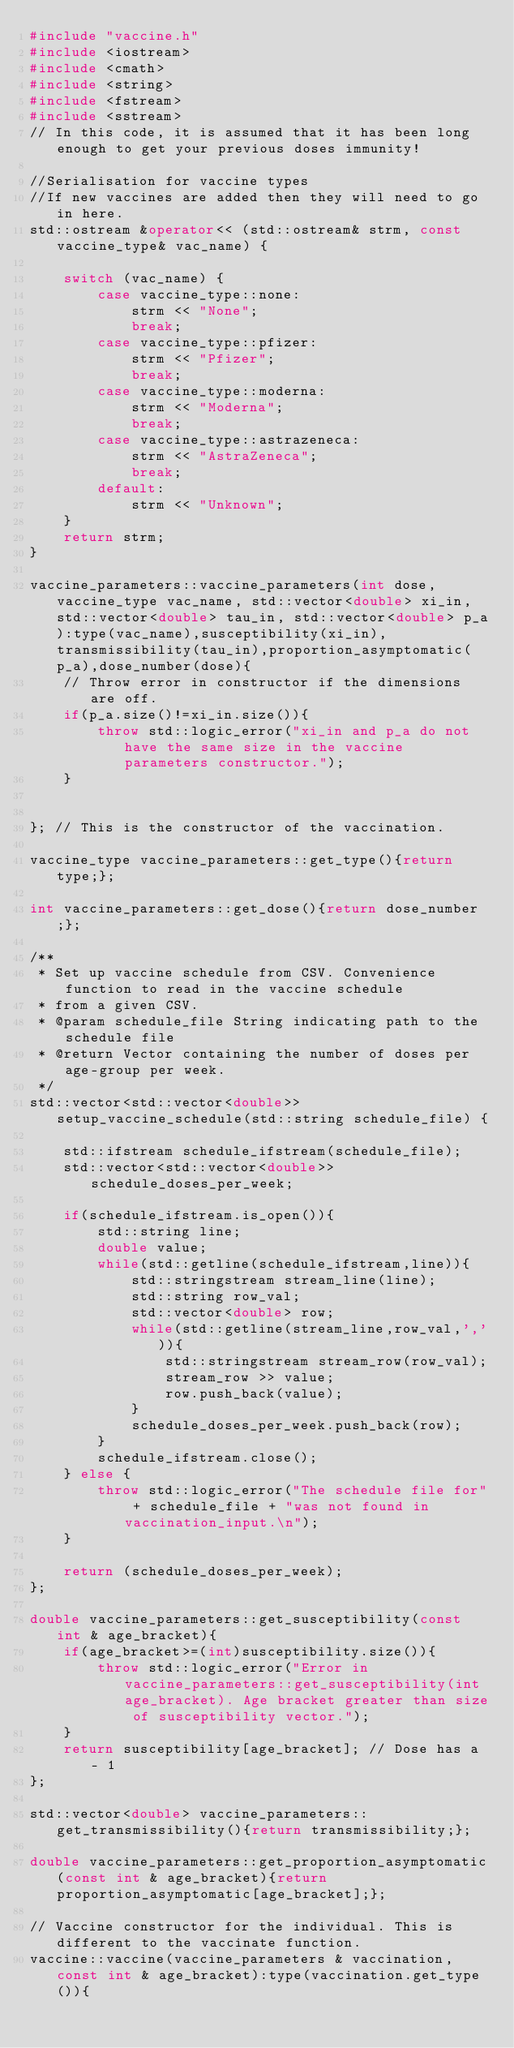<code> <loc_0><loc_0><loc_500><loc_500><_C++_>#include "vaccine.h"
#include <iostream>
#include <cmath>
#include <string>
#include <fstream>
#include <sstream>
// In this code, it is assumed that it has been long enough to get your previous doses immunity!

//Serialisation for vaccine types
//If new vaccines are added then they will need to go in here.
std::ostream &operator<< (std::ostream& strm, const vaccine_type& vac_name) {
    
    switch (vac_name) {
        case vaccine_type::none:
            strm << "None";
            break;
        case vaccine_type::pfizer:
            strm << "Pfizer";
            break;
        case vaccine_type::moderna:
            strm << "Moderna";
            break;
        case vaccine_type::astrazeneca:
            strm << "AstraZeneca";
            break;
        default:
            strm << "Unknown";
    }
    return strm;
}

vaccine_parameters::vaccine_parameters(int dose, vaccine_type vac_name, std::vector<double> xi_in, std::vector<double> tau_in, std::vector<double> p_a):type(vac_name),susceptibility(xi_in),transmissibility(tau_in),proportion_asymptomatic(p_a),dose_number(dose){
    // Throw error in constructor if the dimensions are off.
    if(p_a.size()!=xi_in.size()){
        throw std::logic_error("xi_in and p_a do not have the same size in the vaccine parameters constructor.");
    }
    
    
}; // This is the constructor of the vaccination.

vaccine_type vaccine_parameters::get_type(){return type;};

int vaccine_parameters::get_dose(){return dose_number;};

/**
 * Set up vaccine schedule from CSV. Convenience function to read in the vaccine schedule
 * from a given CSV.
 * @param schedule_file String indicating path to the schedule file
 * @return Vector containing the number of doses per age-group per week.
 */
std::vector<std::vector<double>> setup_vaccine_schedule(std::string schedule_file) {
    
    std::ifstream schedule_ifstream(schedule_file);
    std::vector<std::vector<double>> schedule_doses_per_week;

    if(schedule_ifstream.is_open()){
        std::string line;
        double value;
        while(std::getline(schedule_ifstream,line)){
            std::stringstream stream_line(line);
            std::string row_val;
            std::vector<double> row;
            while(std::getline(stream_line,row_val,',')){
                std::stringstream stream_row(row_val);
                stream_row >> value;
                row.push_back(value);
            }
            schedule_doses_per_week.push_back(row);
        }
        schedule_ifstream.close();
    } else {
        throw std::logic_error("The schedule file for" + schedule_file + "was not found in vaccination_input.\n");
    }

    return (schedule_doses_per_week);
};

double vaccine_parameters::get_susceptibility(const int & age_bracket){
    if(age_bracket>=(int)susceptibility.size()){
        throw std::logic_error("Error in vaccine_parameters::get_susceptibility(int age_bracket). Age bracket greater than size of susceptibility vector.");
    }
    return susceptibility[age_bracket]; // Dose has a - 1
};

std::vector<double> vaccine_parameters::get_transmissibility(){return transmissibility;};

double vaccine_parameters::get_proportion_asymptomatic(const int & age_bracket){return proportion_asymptomatic[age_bracket];};

// Vaccine constructor for the individual. This is different to the vaccinate function.
vaccine::vaccine(vaccine_parameters & vaccination, const int & age_bracket):type(vaccination.get_type()){
    </code> 